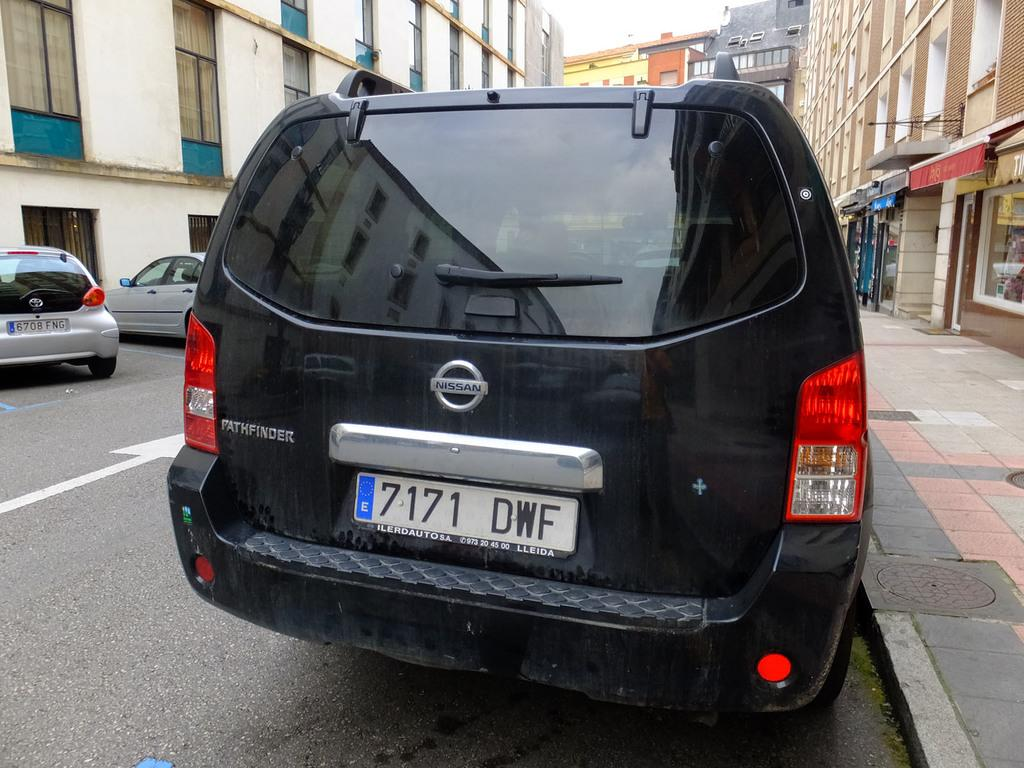What color is the car that is on the road in the image? There is a black color car on the road in the image. How many silver color cars are on the left side in the image? There are two silver color cars on the left side in the image. What can be seen in the background of the image? There are buildings in the background of the image. What type of thunder can be heard in the background of the image? There is no thunder present in the image; it is a still picture and does not have any sound. 